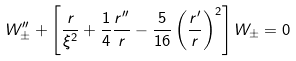<formula> <loc_0><loc_0><loc_500><loc_500>W _ { \pm } ^ { \prime \prime } + \left [ \frac { r } { \xi ^ { 2 } } + \frac { 1 } { 4 } \frac { r ^ { \prime \prime } } { r } - \frac { 5 } { 1 6 } \left ( \frac { r ^ { \prime } } { r } \right ) ^ { 2 } \right ] W _ { \pm } = 0</formula> 